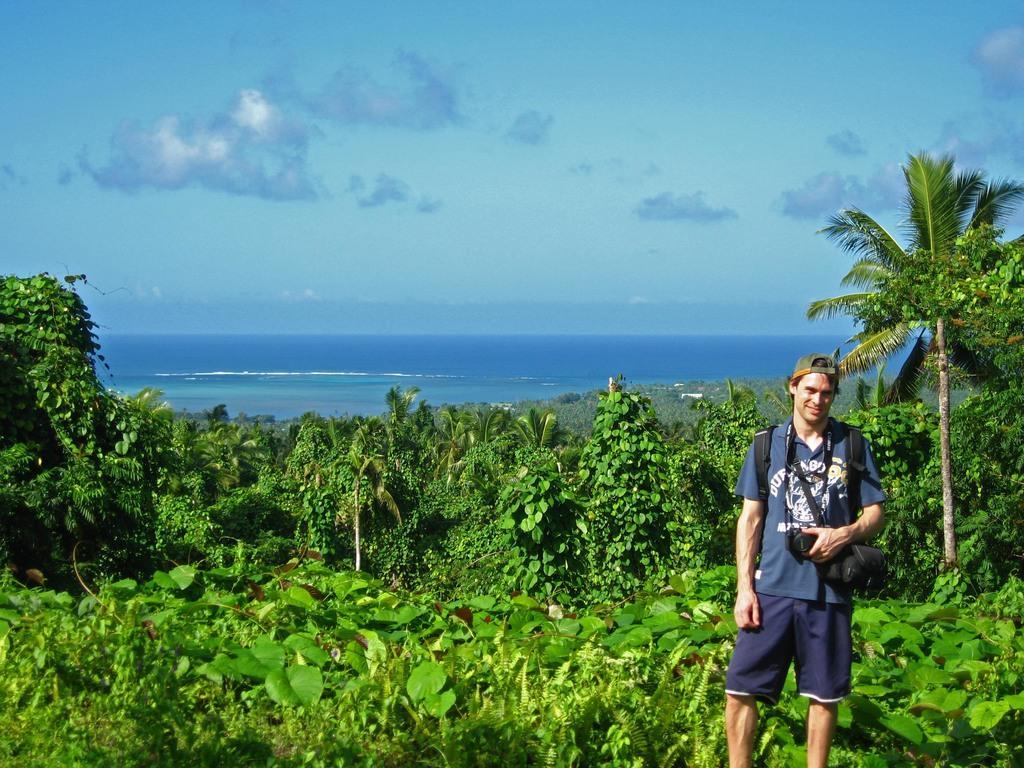Describe this image in one or two sentences. There is a person standing in the foreground area of the image, by holding a camera. There are plants, trees, water and the sky in the background. 